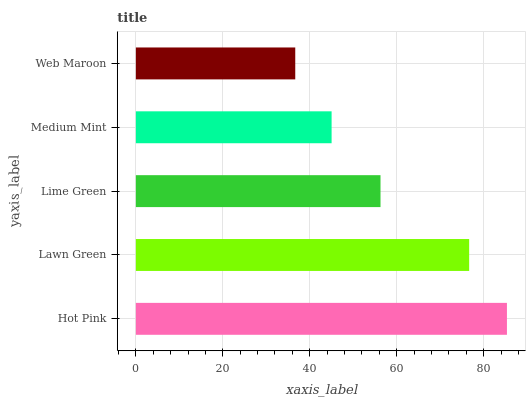Is Web Maroon the minimum?
Answer yes or no. Yes. Is Hot Pink the maximum?
Answer yes or no. Yes. Is Lawn Green the minimum?
Answer yes or no. No. Is Lawn Green the maximum?
Answer yes or no. No. Is Hot Pink greater than Lawn Green?
Answer yes or no. Yes. Is Lawn Green less than Hot Pink?
Answer yes or no. Yes. Is Lawn Green greater than Hot Pink?
Answer yes or no. No. Is Hot Pink less than Lawn Green?
Answer yes or no. No. Is Lime Green the high median?
Answer yes or no. Yes. Is Lime Green the low median?
Answer yes or no. Yes. Is Medium Mint the high median?
Answer yes or no. No. Is Medium Mint the low median?
Answer yes or no. No. 